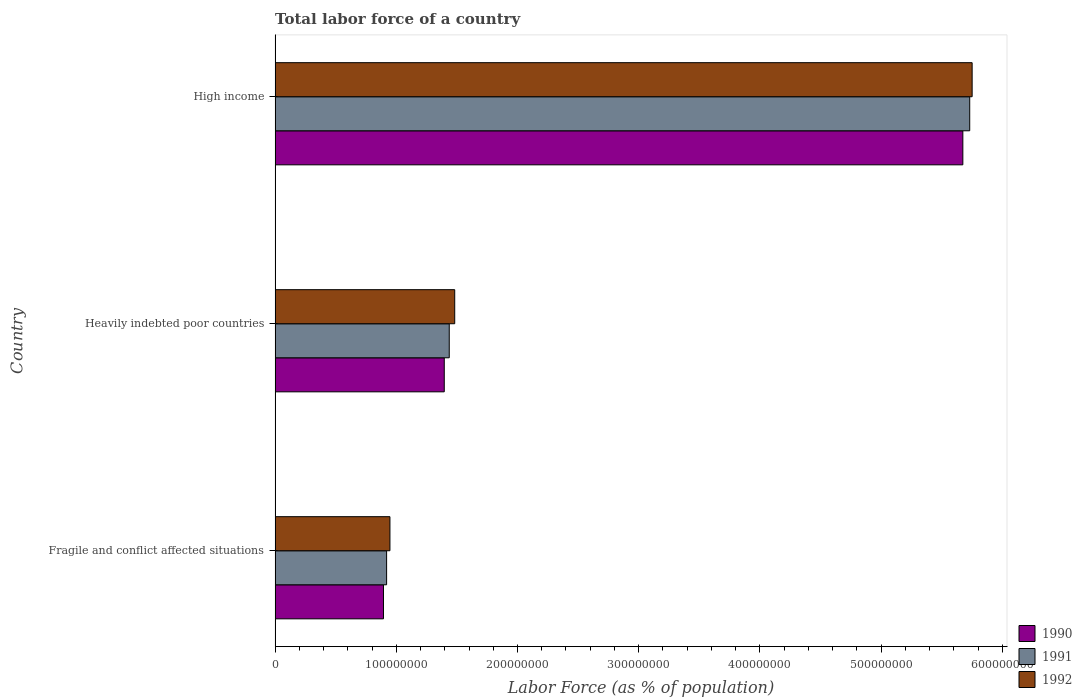How many different coloured bars are there?
Offer a very short reply. 3. How many groups of bars are there?
Your answer should be compact. 3. Are the number of bars per tick equal to the number of legend labels?
Make the answer very short. Yes. What is the label of the 2nd group of bars from the top?
Ensure brevity in your answer.  Heavily indebted poor countries. In how many cases, is the number of bars for a given country not equal to the number of legend labels?
Make the answer very short. 0. What is the percentage of labor force in 1992 in Heavily indebted poor countries?
Your answer should be compact. 1.48e+08. Across all countries, what is the maximum percentage of labor force in 1992?
Your answer should be compact. 5.75e+08. Across all countries, what is the minimum percentage of labor force in 1991?
Make the answer very short. 9.20e+07. In which country was the percentage of labor force in 1990 maximum?
Ensure brevity in your answer.  High income. In which country was the percentage of labor force in 1990 minimum?
Your response must be concise. Fragile and conflict affected situations. What is the total percentage of labor force in 1990 in the graph?
Your response must be concise. 7.96e+08. What is the difference between the percentage of labor force in 1990 in Heavily indebted poor countries and that in High income?
Ensure brevity in your answer.  -4.28e+08. What is the difference between the percentage of labor force in 1992 in Heavily indebted poor countries and the percentage of labor force in 1991 in High income?
Your answer should be very brief. -4.25e+08. What is the average percentage of labor force in 1992 per country?
Provide a short and direct response. 2.73e+08. What is the difference between the percentage of labor force in 1992 and percentage of labor force in 1990 in Fragile and conflict affected situations?
Your answer should be very brief. 5.32e+06. In how many countries, is the percentage of labor force in 1992 greater than 20000000 %?
Ensure brevity in your answer.  3. What is the ratio of the percentage of labor force in 1991 in Heavily indebted poor countries to that in High income?
Your answer should be compact. 0.25. Is the percentage of labor force in 1990 in Fragile and conflict affected situations less than that in High income?
Provide a succinct answer. Yes. What is the difference between the highest and the second highest percentage of labor force in 1991?
Your response must be concise. 4.29e+08. What is the difference between the highest and the lowest percentage of labor force in 1992?
Keep it short and to the point. 4.80e+08. In how many countries, is the percentage of labor force in 1990 greater than the average percentage of labor force in 1990 taken over all countries?
Make the answer very short. 1. Is the sum of the percentage of labor force in 1991 in Heavily indebted poor countries and High income greater than the maximum percentage of labor force in 1990 across all countries?
Provide a short and direct response. Yes. What does the 1st bar from the bottom in High income represents?
Offer a terse response. 1990. How many bars are there?
Keep it short and to the point. 9. Are all the bars in the graph horizontal?
Offer a very short reply. Yes. How many countries are there in the graph?
Provide a short and direct response. 3. What is the difference between two consecutive major ticks on the X-axis?
Your response must be concise. 1.00e+08. Does the graph contain any zero values?
Offer a very short reply. No. How many legend labels are there?
Your answer should be compact. 3. How are the legend labels stacked?
Make the answer very short. Vertical. What is the title of the graph?
Keep it short and to the point. Total labor force of a country. Does "1991" appear as one of the legend labels in the graph?
Make the answer very short. Yes. What is the label or title of the X-axis?
Your answer should be very brief. Labor Force (as % of population). What is the label or title of the Y-axis?
Your answer should be very brief. Country. What is the Labor Force (as % of population) of 1990 in Fragile and conflict affected situations?
Give a very brief answer. 8.94e+07. What is the Labor Force (as % of population) of 1991 in Fragile and conflict affected situations?
Provide a succinct answer. 9.20e+07. What is the Labor Force (as % of population) of 1992 in Fragile and conflict affected situations?
Give a very brief answer. 9.48e+07. What is the Labor Force (as % of population) in 1990 in Heavily indebted poor countries?
Provide a succinct answer. 1.40e+08. What is the Labor Force (as % of population) in 1991 in Heavily indebted poor countries?
Keep it short and to the point. 1.44e+08. What is the Labor Force (as % of population) of 1992 in Heavily indebted poor countries?
Your response must be concise. 1.48e+08. What is the Labor Force (as % of population) of 1990 in High income?
Your response must be concise. 5.67e+08. What is the Labor Force (as % of population) of 1991 in High income?
Provide a succinct answer. 5.73e+08. What is the Labor Force (as % of population) in 1992 in High income?
Provide a succinct answer. 5.75e+08. Across all countries, what is the maximum Labor Force (as % of population) of 1990?
Your answer should be compact. 5.67e+08. Across all countries, what is the maximum Labor Force (as % of population) in 1991?
Make the answer very short. 5.73e+08. Across all countries, what is the maximum Labor Force (as % of population) of 1992?
Offer a terse response. 5.75e+08. Across all countries, what is the minimum Labor Force (as % of population) of 1990?
Give a very brief answer. 8.94e+07. Across all countries, what is the minimum Labor Force (as % of population) in 1991?
Make the answer very short. 9.20e+07. Across all countries, what is the minimum Labor Force (as % of population) in 1992?
Provide a succinct answer. 9.48e+07. What is the total Labor Force (as % of population) in 1990 in the graph?
Provide a short and direct response. 7.96e+08. What is the total Labor Force (as % of population) of 1991 in the graph?
Keep it short and to the point. 8.09e+08. What is the total Labor Force (as % of population) of 1992 in the graph?
Provide a short and direct response. 8.18e+08. What is the difference between the Labor Force (as % of population) of 1990 in Fragile and conflict affected situations and that in Heavily indebted poor countries?
Give a very brief answer. -5.01e+07. What is the difference between the Labor Force (as % of population) in 1991 in Fragile and conflict affected situations and that in Heavily indebted poor countries?
Provide a succinct answer. -5.17e+07. What is the difference between the Labor Force (as % of population) in 1992 in Fragile and conflict affected situations and that in Heavily indebted poor countries?
Your answer should be very brief. -5.34e+07. What is the difference between the Labor Force (as % of population) in 1990 in Fragile and conflict affected situations and that in High income?
Give a very brief answer. -4.78e+08. What is the difference between the Labor Force (as % of population) in 1991 in Fragile and conflict affected situations and that in High income?
Ensure brevity in your answer.  -4.81e+08. What is the difference between the Labor Force (as % of population) of 1992 in Fragile and conflict affected situations and that in High income?
Make the answer very short. -4.80e+08. What is the difference between the Labor Force (as % of population) of 1990 in Heavily indebted poor countries and that in High income?
Your answer should be very brief. -4.28e+08. What is the difference between the Labor Force (as % of population) of 1991 in Heavily indebted poor countries and that in High income?
Your response must be concise. -4.29e+08. What is the difference between the Labor Force (as % of population) of 1992 in Heavily indebted poor countries and that in High income?
Offer a very short reply. -4.27e+08. What is the difference between the Labor Force (as % of population) of 1990 in Fragile and conflict affected situations and the Labor Force (as % of population) of 1991 in Heavily indebted poor countries?
Your response must be concise. -5.43e+07. What is the difference between the Labor Force (as % of population) in 1990 in Fragile and conflict affected situations and the Labor Force (as % of population) in 1992 in Heavily indebted poor countries?
Your answer should be compact. -5.88e+07. What is the difference between the Labor Force (as % of population) of 1991 in Fragile and conflict affected situations and the Labor Force (as % of population) of 1992 in Heavily indebted poor countries?
Your response must be concise. -5.62e+07. What is the difference between the Labor Force (as % of population) in 1990 in Fragile and conflict affected situations and the Labor Force (as % of population) in 1991 in High income?
Offer a terse response. -4.84e+08. What is the difference between the Labor Force (as % of population) of 1990 in Fragile and conflict affected situations and the Labor Force (as % of population) of 1992 in High income?
Offer a terse response. -4.86e+08. What is the difference between the Labor Force (as % of population) in 1991 in Fragile and conflict affected situations and the Labor Force (as % of population) in 1992 in High income?
Offer a terse response. -4.83e+08. What is the difference between the Labor Force (as % of population) in 1990 in Heavily indebted poor countries and the Labor Force (as % of population) in 1991 in High income?
Offer a very short reply. -4.34e+08. What is the difference between the Labor Force (as % of population) in 1990 in Heavily indebted poor countries and the Labor Force (as % of population) in 1992 in High income?
Make the answer very short. -4.36e+08. What is the difference between the Labor Force (as % of population) of 1991 in Heavily indebted poor countries and the Labor Force (as % of population) of 1992 in High income?
Offer a very short reply. -4.31e+08. What is the average Labor Force (as % of population) of 1990 per country?
Ensure brevity in your answer.  2.65e+08. What is the average Labor Force (as % of population) of 1991 per country?
Keep it short and to the point. 2.70e+08. What is the average Labor Force (as % of population) of 1992 per country?
Ensure brevity in your answer.  2.73e+08. What is the difference between the Labor Force (as % of population) in 1990 and Labor Force (as % of population) in 1991 in Fragile and conflict affected situations?
Keep it short and to the point. -2.58e+06. What is the difference between the Labor Force (as % of population) in 1990 and Labor Force (as % of population) in 1992 in Fragile and conflict affected situations?
Make the answer very short. -5.32e+06. What is the difference between the Labor Force (as % of population) in 1991 and Labor Force (as % of population) in 1992 in Fragile and conflict affected situations?
Give a very brief answer. -2.74e+06. What is the difference between the Labor Force (as % of population) in 1990 and Labor Force (as % of population) in 1991 in Heavily indebted poor countries?
Ensure brevity in your answer.  -4.12e+06. What is the difference between the Labor Force (as % of population) in 1990 and Labor Force (as % of population) in 1992 in Heavily indebted poor countries?
Your answer should be compact. -8.62e+06. What is the difference between the Labor Force (as % of population) of 1991 and Labor Force (as % of population) of 1992 in Heavily indebted poor countries?
Provide a succinct answer. -4.50e+06. What is the difference between the Labor Force (as % of population) in 1990 and Labor Force (as % of population) in 1991 in High income?
Your answer should be compact. -5.67e+06. What is the difference between the Labor Force (as % of population) of 1990 and Labor Force (as % of population) of 1992 in High income?
Give a very brief answer. -7.67e+06. What is the difference between the Labor Force (as % of population) in 1991 and Labor Force (as % of population) in 1992 in High income?
Provide a succinct answer. -2.00e+06. What is the ratio of the Labor Force (as % of population) of 1990 in Fragile and conflict affected situations to that in Heavily indebted poor countries?
Your answer should be compact. 0.64. What is the ratio of the Labor Force (as % of population) in 1991 in Fragile and conflict affected situations to that in Heavily indebted poor countries?
Keep it short and to the point. 0.64. What is the ratio of the Labor Force (as % of population) in 1992 in Fragile and conflict affected situations to that in Heavily indebted poor countries?
Provide a succinct answer. 0.64. What is the ratio of the Labor Force (as % of population) of 1990 in Fragile and conflict affected situations to that in High income?
Your response must be concise. 0.16. What is the ratio of the Labor Force (as % of population) of 1991 in Fragile and conflict affected situations to that in High income?
Ensure brevity in your answer.  0.16. What is the ratio of the Labor Force (as % of population) in 1992 in Fragile and conflict affected situations to that in High income?
Provide a succinct answer. 0.16. What is the ratio of the Labor Force (as % of population) in 1990 in Heavily indebted poor countries to that in High income?
Ensure brevity in your answer.  0.25. What is the ratio of the Labor Force (as % of population) of 1991 in Heavily indebted poor countries to that in High income?
Offer a terse response. 0.25. What is the ratio of the Labor Force (as % of population) of 1992 in Heavily indebted poor countries to that in High income?
Provide a short and direct response. 0.26. What is the difference between the highest and the second highest Labor Force (as % of population) in 1990?
Offer a terse response. 4.28e+08. What is the difference between the highest and the second highest Labor Force (as % of population) of 1991?
Offer a very short reply. 4.29e+08. What is the difference between the highest and the second highest Labor Force (as % of population) in 1992?
Your response must be concise. 4.27e+08. What is the difference between the highest and the lowest Labor Force (as % of population) in 1990?
Your response must be concise. 4.78e+08. What is the difference between the highest and the lowest Labor Force (as % of population) of 1991?
Ensure brevity in your answer.  4.81e+08. What is the difference between the highest and the lowest Labor Force (as % of population) in 1992?
Keep it short and to the point. 4.80e+08. 